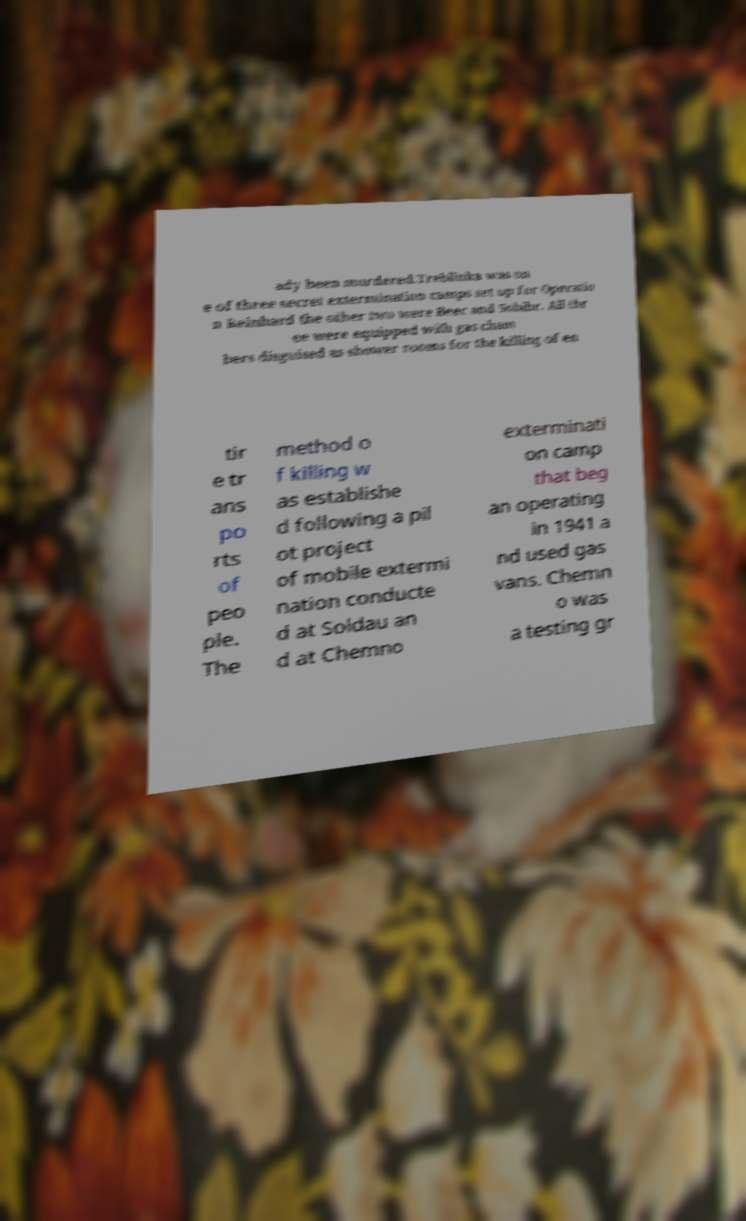There's text embedded in this image that I need extracted. Can you transcribe it verbatim? ady been murdered.Treblinka was on e of three secret extermination camps set up for Operatio n Reinhard the other two were Beec and Sobibr. All thr ee were equipped with gas cham bers disguised as shower rooms for the killing of en tir e tr ans po rts of peo ple. The method o f killing w as establishe d following a pil ot project of mobile extermi nation conducte d at Soldau an d at Chemno exterminati on camp that beg an operating in 1941 a nd used gas vans. Chemn o was a testing gr 